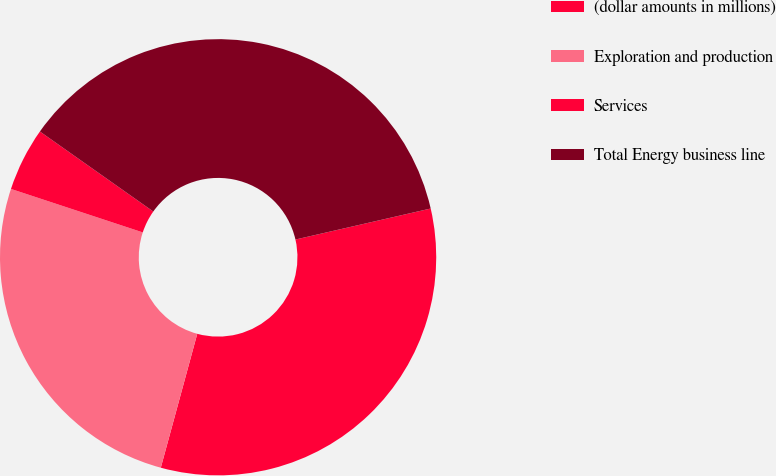Convert chart. <chart><loc_0><loc_0><loc_500><loc_500><pie_chart><fcel>(dollar amounts in millions)<fcel>Exploration and production<fcel>Services<fcel>Total Energy business line<nl><fcel>32.82%<fcel>25.84%<fcel>4.71%<fcel>36.63%<nl></chart> 